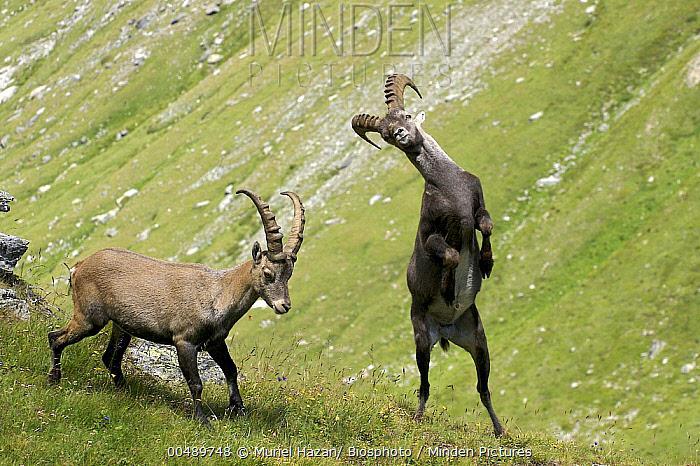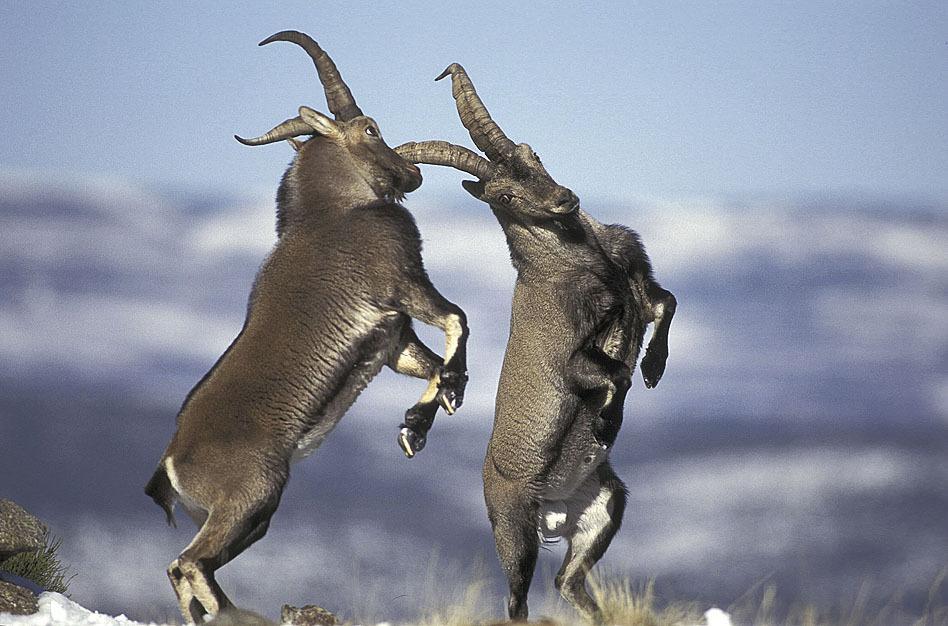The first image is the image on the left, the second image is the image on the right. Assess this claim about the two images: "There are two Ibex Rams standing on greenery.". Correct or not? Answer yes or no. Yes. 